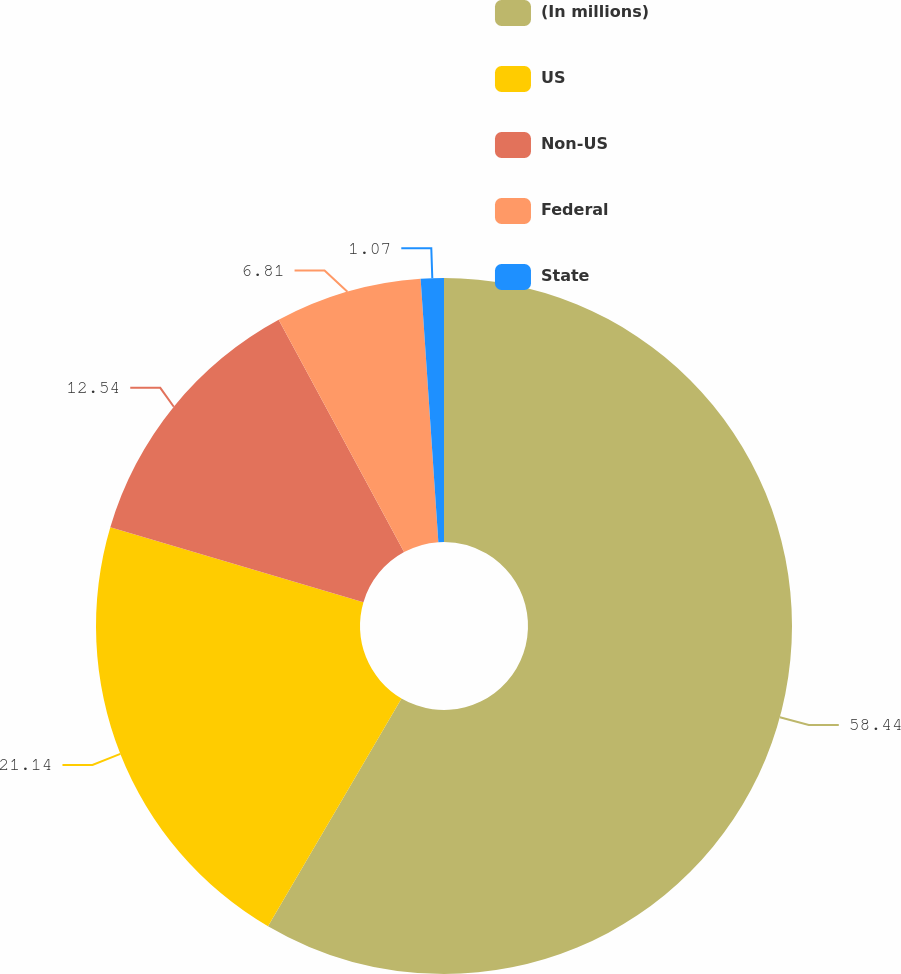Convert chart to OTSL. <chart><loc_0><loc_0><loc_500><loc_500><pie_chart><fcel>(In millions)<fcel>US<fcel>Non-US<fcel>Federal<fcel>State<nl><fcel>58.44%<fcel>21.14%<fcel>12.54%<fcel>6.81%<fcel>1.07%<nl></chart> 